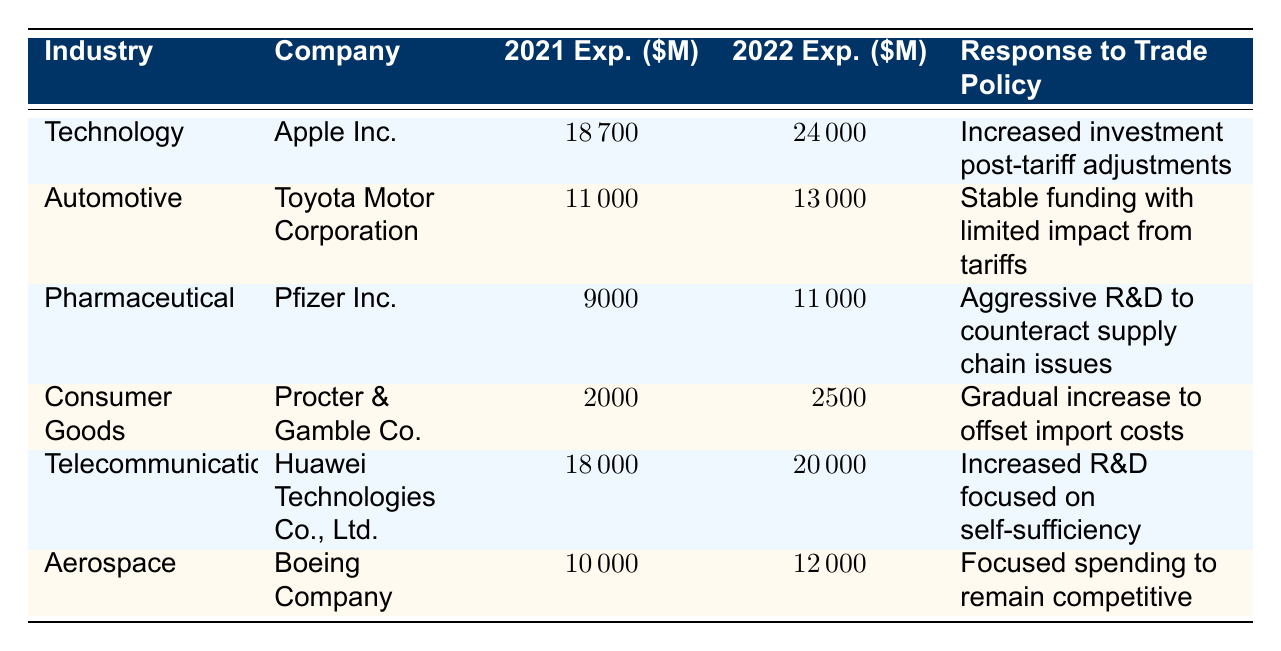What was the R&D expenditure for Pfizer Inc. in 2022? The table lists the expenditures for Pfizer Inc. under the Pharmaceutical industry, showing a value of 11000 million USD for the year 2022.
Answer: 11000 million USD Which company had the highest increase in R&D expenditures from 2021 to 2022? To find the highest increase, we subtract the 2021 expenditure from the 2022 expenditure for each company. For Apple Inc.: 24000 - 18700 = 5300 million USD; for Toyota: 13000 - 11000 = 2000 million USD; for Pfizer: 11000 - 9000 = 2000 million USD; for Procter & Gamble: 2500 - 2000 = 500 million USD; for Huawei: 20000 - 18000 = 2000 million USD; for Boeing: 12000 - 10000 = 2000 million USD. Thus, Apple Inc. had the largest increase of 5300 million USD.
Answer: Apple Inc Is the response to trade policy for the Automotive industry characterized by stable funding? The table includes the response for Toyota Motor Corporation in the Automotive industry, noting that their response was "Stable funding with limited impact from tariffs." Hence, the statement is true.
Answer: Yes What were the total R&D expenditures (combined) for Technology and Telecommunications in 2021? We sum the expenditures for both industries in 2021: Apple Inc. (18700 million USD) + Huawei Technologies (18000 million USD) = 36700 million USD.
Answer: 36700 million USD Did Procter & Gamble Co. increase its R&D expenditure in 2022 compared to 2021? The table shows that Procter & Gamble Co. had an expenditure of 2000 million USD in 2021 and 2500 million USD in 2022, indicating an increase.
Answer: Yes What is the average R&D expenditure in 2022 across all listed companies? We calculate the average by summing the 2022 expenditures for all companies: (24000 + 13000 + 11000 + 2500 + 20000 + 12000) = 83500 million USD, then divide by the number of companies (6): 83500 / 6 = 13916.67 million USD.
Answer: 13916.67 million USD Which industry experienced aggressive R&D efforts in response to trade policy? According to the table, Pfizer Inc. in the Pharmaceutical industry reported "Aggressive R&D to counteract supply chain issues" as their response to trade policies.
Answer: Pharmaceutical Is the R&D expenditure for Boeing Company in 2022 higher than its expenditure in 2021? The expenditure for Boeing Company in 2021 was 10000 million USD, and in 2022, it was 12000 million USD, indicating that it indeed increased.
Answer: Yes 